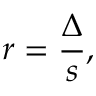<formula> <loc_0><loc_0><loc_500><loc_500>r = { \frac { \Delta } { s } } ,</formula> 